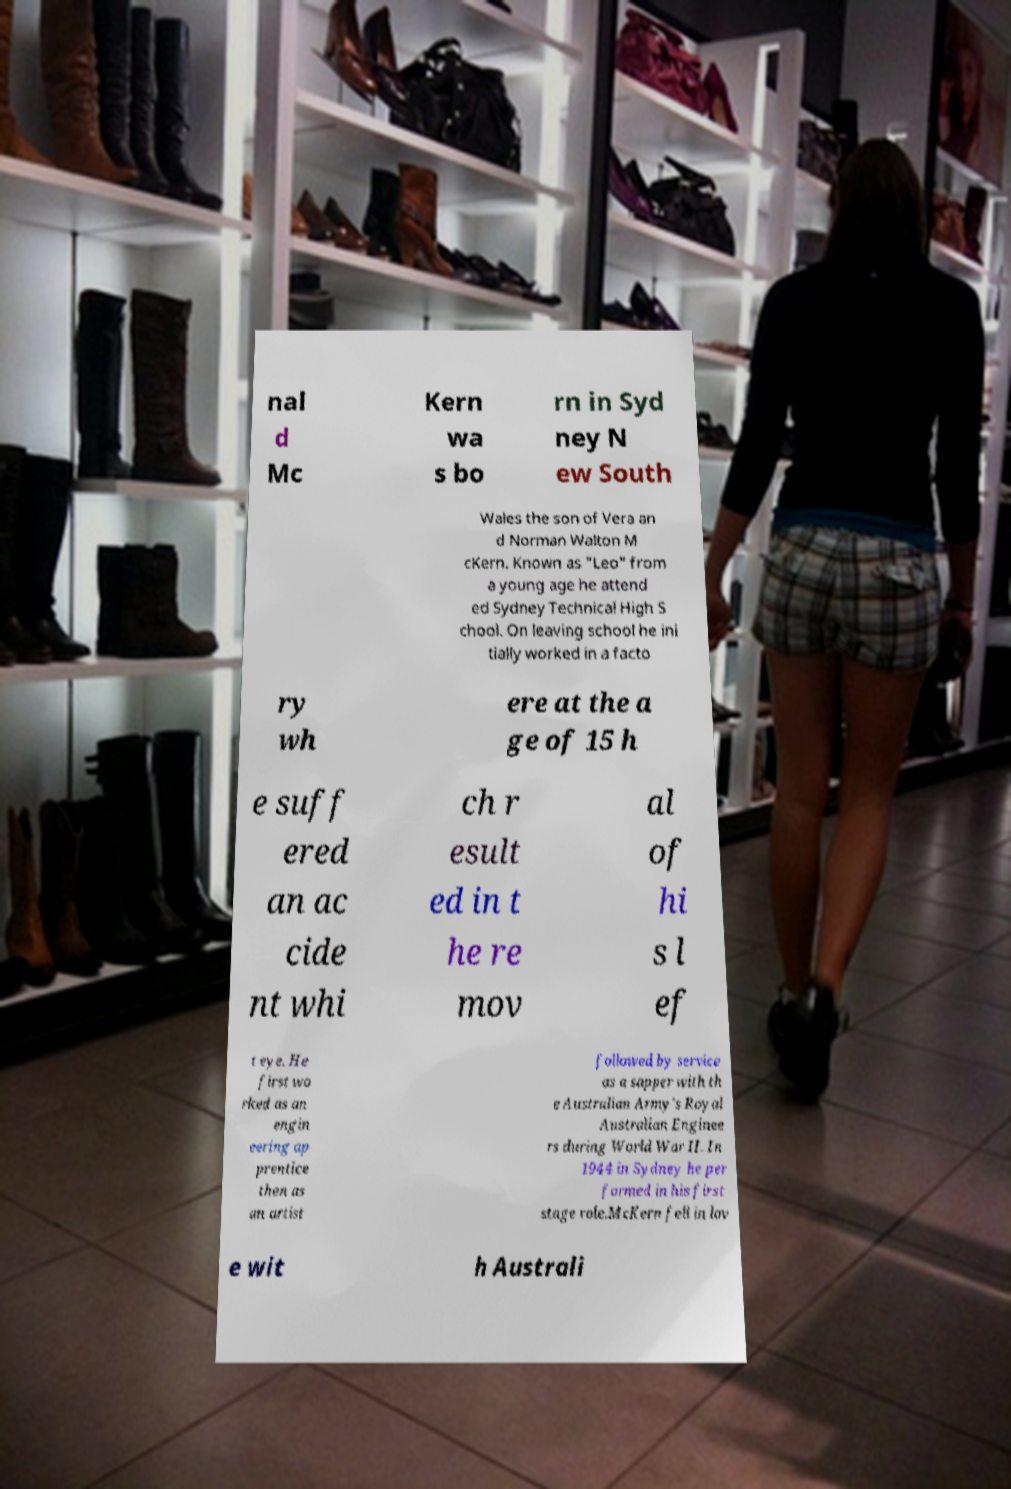Could you assist in decoding the text presented in this image and type it out clearly? nal d Mc Kern wa s bo rn in Syd ney N ew South Wales the son of Vera an d Norman Walton M cKern. Known as "Leo" from a young age he attend ed Sydney Technical High S chool. On leaving school he ini tially worked in a facto ry wh ere at the a ge of 15 h e suff ered an ac cide nt whi ch r esult ed in t he re mov al of hi s l ef t eye. He first wo rked as an engin eering ap prentice then as an artist followed by service as a sapper with th e Australian Army's Royal Australian Enginee rs during World War II. In 1944 in Sydney he per formed in his first stage role.McKern fell in lov e wit h Australi 